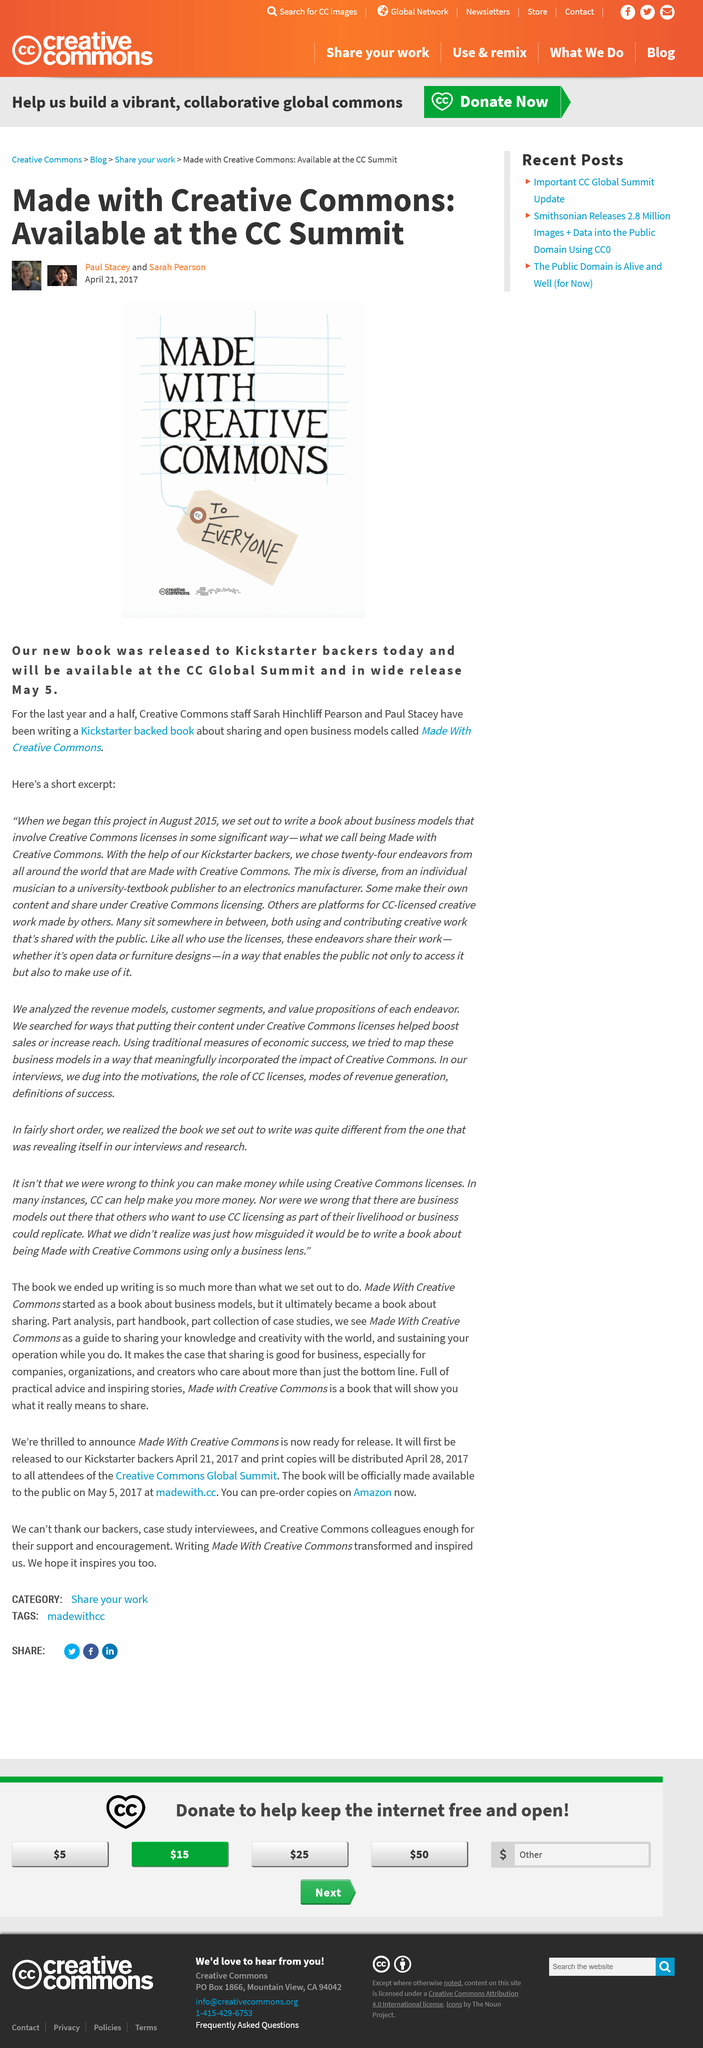Outline some significant characteristics in this image. The names of the people in the photos are Paul Stacey and Sarah Pearson. I hereby declare that the book in question is called 'Made with Creative Commons,' and it is properly labeled and attributed to its rightful creators. The wide release of the book is on May 5th, 2023. 